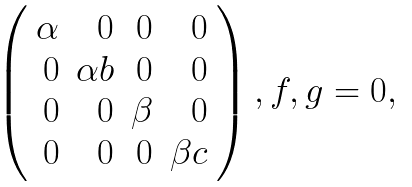<formula> <loc_0><loc_0><loc_500><loc_500>\begin{array} { l } \left ( \begin{array} { r r r r } \alpha & 0 & 0 & 0 \\ 0 & \alpha b & 0 & 0 \\ 0 & 0 & \beta & 0 \\ 0 & 0 & 0 & \beta c \end{array} \right ) , f , g = 0 , \end{array}</formula> 